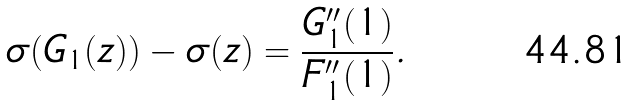<formula> <loc_0><loc_0><loc_500><loc_500>\sigma ( G _ { 1 } ( z ) ) - \sigma ( z ) = \frac { G ^ { \prime \prime } _ { 1 } ( 1 ) } { F ^ { \prime \prime } _ { 1 } ( 1 ) } .</formula> 